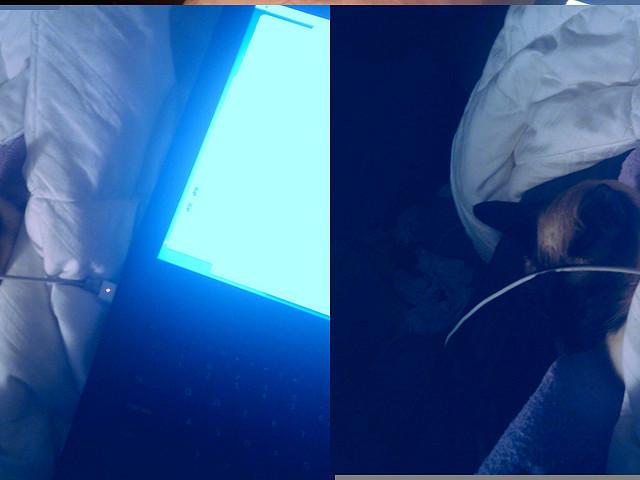Are both pictures the same?
Concise answer only. No. Is the computer screen turned on?
Keep it brief. Yes. Where is the cat?
Be succinct. On bed. 